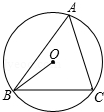Please explain the significance of the central angle in circle geometry and how it relates to arcs and sectors. In circle geometry, the central angle (like angle O in our diagram) plays a crucial role in defining the proportions of arcs and sectors of a circle. It directly determines the size of the arc and the corresponding sector it spans. For example, the larger the central angle, the larger the arc and its sector. This relationship is vital in calculations and graphical representations of circle properties, facilitating a thorough understanding of its geometry. 